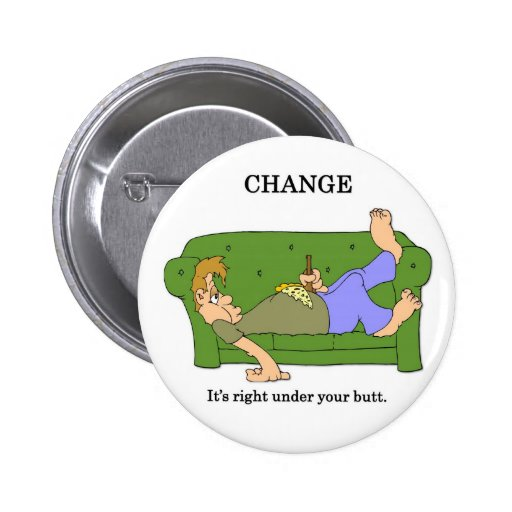If these characters were to have a conversation about their day, what might they say? Character 1: 'You know, I was thinking about how we always find change under this couch. It’s kind of funny, right?' 
Character 2: 'Yeah, it’s like a hidden treasure trove. Makes you wonder what else we might be sitting on in our lives without realizing it.' 
Character 1: 'True. Maybe we should start looking around more often, not just for change, but for opportunities too!' 